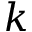Convert formula to latex. <formula><loc_0><loc_0><loc_500><loc_500>k</formula> 